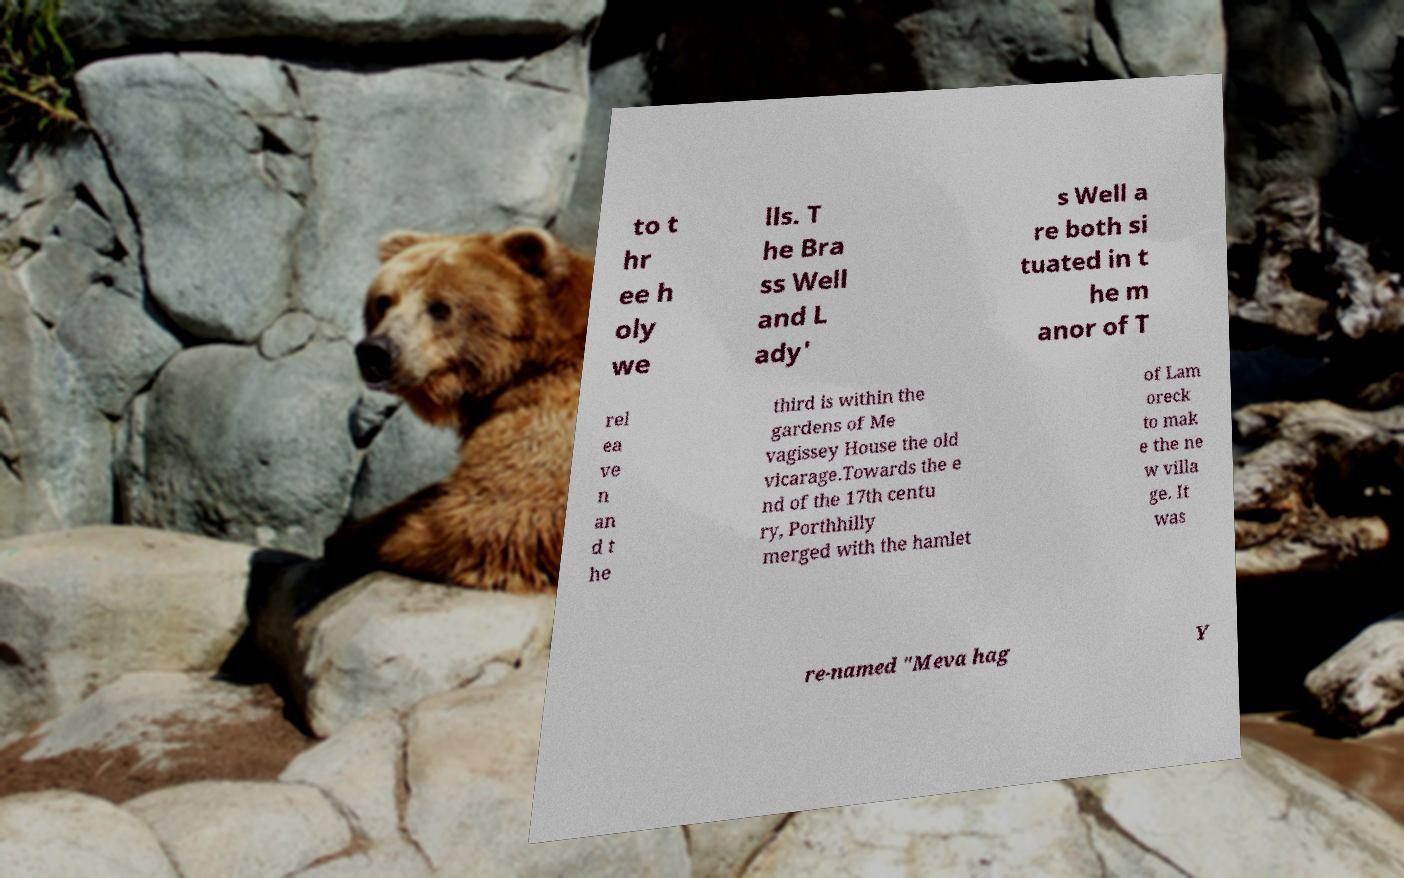I need the written content from this picture converted into text. Can you do that? to t hr ee h oly we lls. T he Bra ss Well and L ady' s Well a re both si tuated in t he m anor of T rel ea ve n an d t he third is within the gardens of Me vagissey House the old vicarage.Towards the e nd of the 17th centu ry, Porthhilly merged with the hamlet of Lam oreck to mak e the ne w villa ge. It was re-named "Meva hag Y 